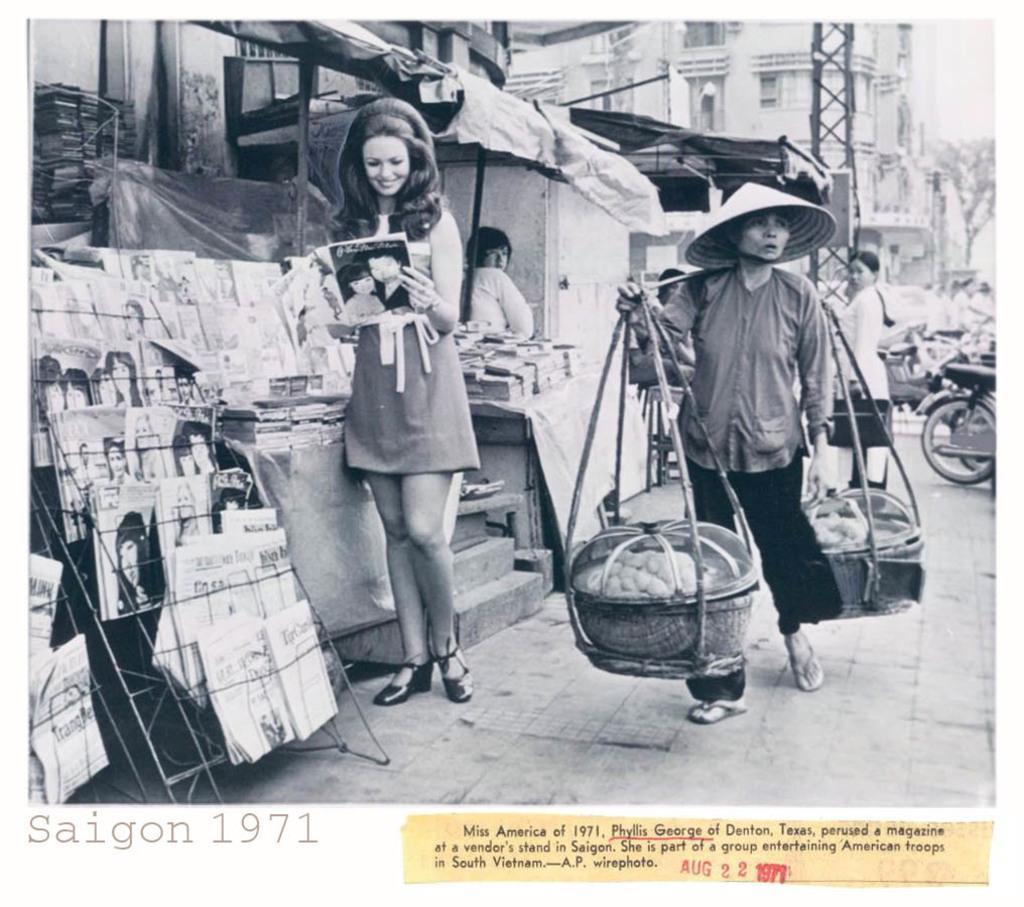How would you summarize this image in a sentence or two? This is a black and white image. On the right we can see the two baskets containing some items and the baskets are hanging on the shoulder of a person. On the left there is a woman wearing a dress, smiling, holding a book and standing on the ground. On the left there is a stand and tables containing many number of books. In the background we can see the buildings, metal rods, vehicles and group of persons and a tree. At the bottom there is a text on the image. 